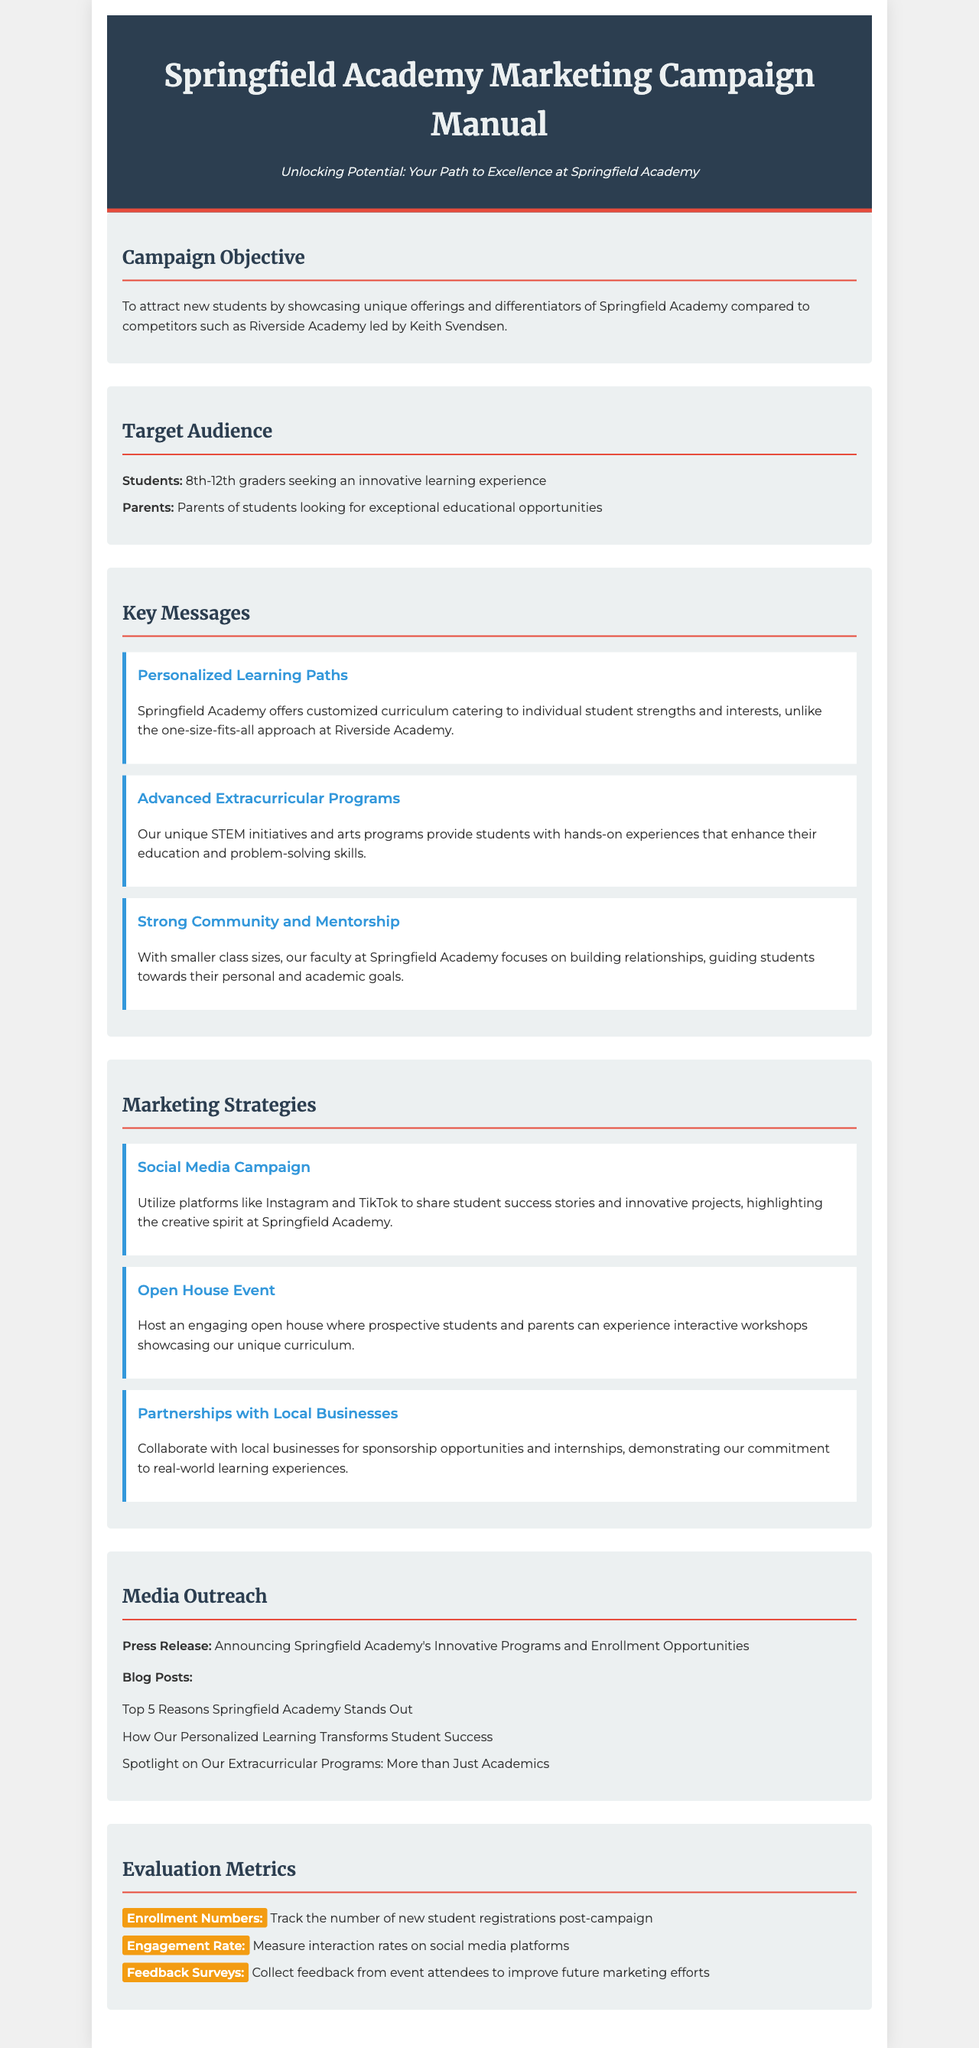What is the title of the document? The title is specified in the header section of the document.
Answer: Springfield Academy Marketing Campaign Manual What is one of the campaign objectives? The campaign objective is outlined in the second section of the document.
Answer: To attract new students Who is the target audience for the campaign? The target audience is detailed in the third section, specifying groups targeted by the campaign.
Answer: Students and Parents Name one key message of Springfield Academy. The key messages are listed under the "Key Messages" section, each with its own description.
Answer: Personalized Learning Paths What is one marketing strategy mentioned in the document? Several strategies are provided in the "Marketing Strategies" section, indicating how to promote the academy's unique offerings.
Answer: Social Media Campaign What is the purpose of the Open House Event? The purpose is stated in the marketing strategy that directly mentions the event for prospective students.
Answer: Experience interactive workshops How will success be measured after the campaign? The "Evaluation Metrics" section outlines how to measure the effectiveness of the marketing campaign.
Answer: Enrollment Numbers What is one of the media outreach methods described? The media outreach section provides various methods for promoting Springfield Academy's programs.
Answer: Press Release How many grade levels are targeted in the campaign? The target grade levels are clearly mentioned in the second section under students.
Answer: 8th-12th graders 